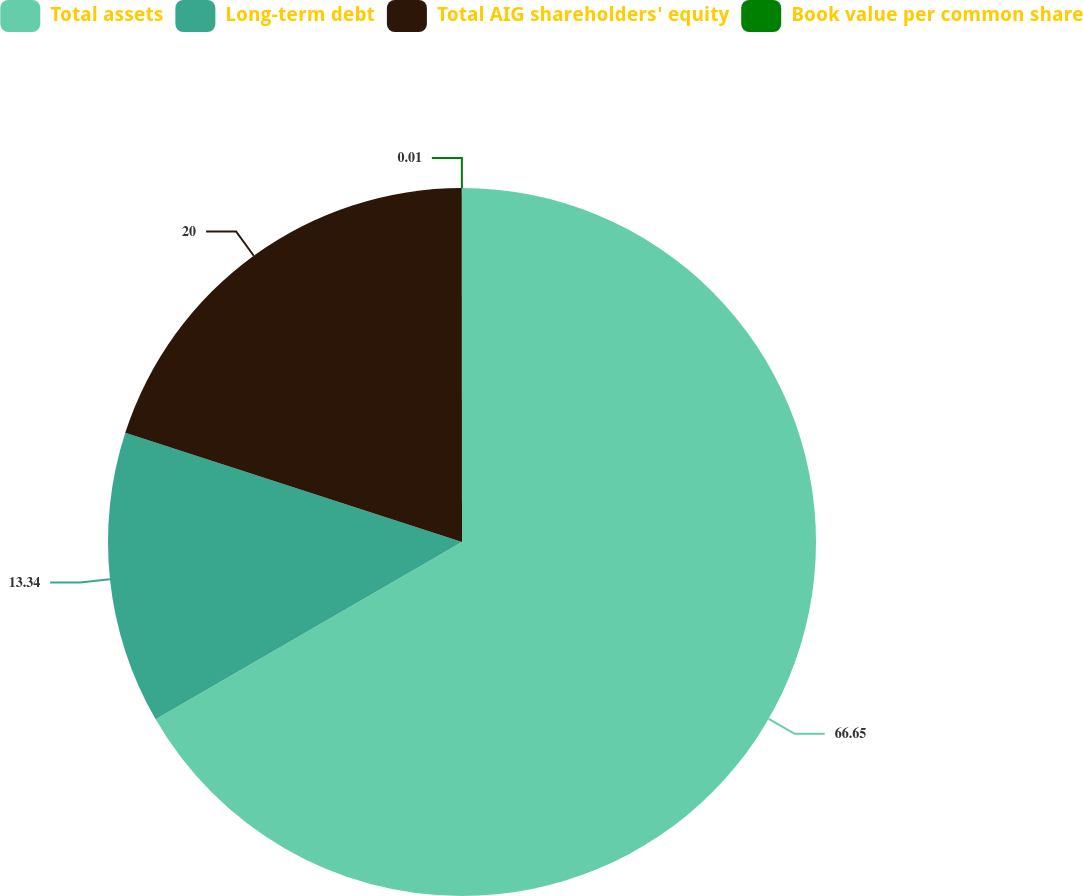<chart> <loc_0><loc_0><loc_500><loc_500><pie_chart><fcel>Total assets<fcel>Long-term debt<fcel>Total AIG shareholders' equity<fcel>Book value per common share<nl><fcel>66.65%<fcel>13.34%<fcel>20.0%<fcel>0.01%<nl></chart> 